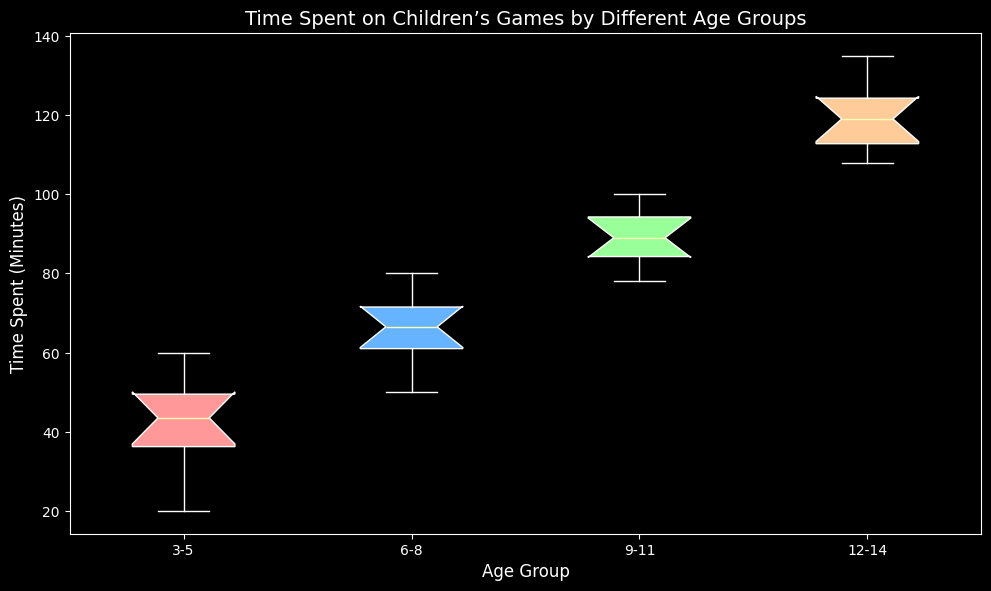Which age group has the highest median time spent on children’s games? Observe the medians marked inside the boxes of each age group. The 12-14 age group has the highest median, which is visible around 120 minutes.
Answer: 12-14 Which age group has the most variability in the time spent on children’s games? The variability is reflected in the height of the box and the distance between the whiskers. The 12-14 age group has the largest box and whiskers, indicating the most variability.
Answer: 12-14 What is the difference between the medians of the 6-8 and 9-11 age groups? Identify the median of each group first. The 6-8 age group has a median around 67 minutes and the 9-11 age group has a median around 90 minutes. The difference is 90 - 67 = 23 minutes.
Answer: 23 minutes Which color represents the 9-11 age group and what does it indicate visually? The 9-11 age group is represented by a green box. This color, along with the height of the box and whiskers, visually indicates the distribution of time spent by this age group, with central values around 90 minutes.
Answer: Green, indicates time distribution around 90 minutes What is the interquartile range (IQR) for the 3-5 age group? The IQR is the range between the first quartile (Q1) and the third quartile (Q3). For the 3-5 age group, Q1 is around 35 minutes and Q3 is about 48 minutes. IQR = Q3 - Q1 = 48 - 35 = 13 minutes.
Answer: 13 minutes Which age group spends the least amount of time on children’s games, and how do you determine this? The 3-5 age group’s minimum whisker end reaches the lowest point around 20 minutes, indicating they spend the least amount of time on children’s games.
Answer: 3-5, minimum whisker around 20 minutes Compare the ranged times spent on children’s games by the 6-8 and 12-14 age groups. Which group has a wider range? The range is determined by the difference between the maximum and minimum whiskers. For the 6-8 age group, the range is 80 - 50 = 30 minutes. For the 12-14 age group, the range is 135 - 108 = 27 minutes. The 6-8 age group has a wider range.
Answer: 6-8 How does the time spent on children’s games change with age based on the box plots? Generally, the box plots show an increase in the median and interquartile range of time spent on games as age increases, indicating older children tend to spend more time on children’s games.
Answer: Increases What visual indication is there that the 6-8 age group has a relatively consistent time spent on children’s games? The relatively small height of the box and whiskers in the 6-8 age group, compared to others, indicates less variability and more consistency in the time spent.
Answer: Small height of box and whiskers Which age group has the lowest upper whisker and what does it signify? The 3-5 age group has the lowest upper whisker, signifying that even the higher end of the time spent distribution is lower compared to other groups.
Answer: 3-5 